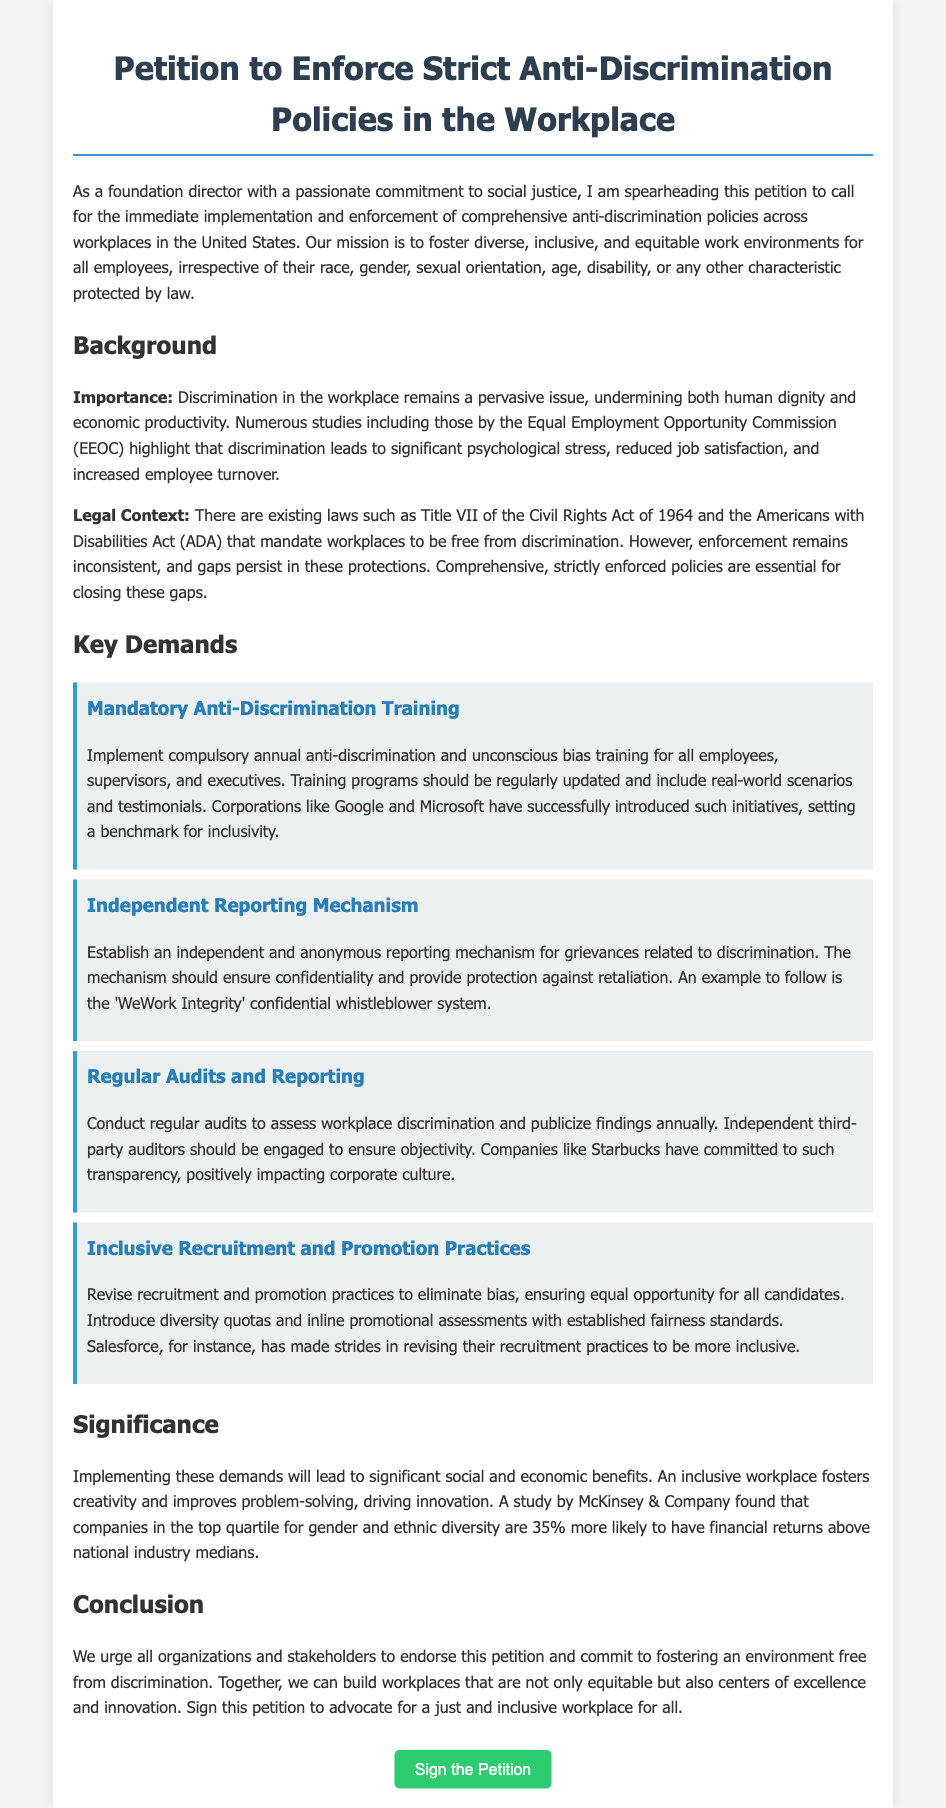what is the title of the petition? The title of the petition is explicitly stated in the document's heading.
Answer: Petition to Enforce Strict Anti-Discrimination Policies in the Workplace who is leading the petition? The introduction section mentions the individual spearheading the petition.
Answer: foundation director what year was the Civil Rights Act enacted? This act is referenced in the legal context of the background section of the document.
Answer: 1964 name one company that introduced inclusive training programs. The demands section includes examples of corporations that have successfully implemented initiatives.
Answer: Google what is one of the key demands of the petition? The section detailing key demands lists several initiatives being called for.
Answer: Mandatory Anti-Discrimination Training how often should anti-discrimination training be conducted? This information is provided in the demands section regarding training frequency.
Answer: annually what is highlighted as a significant benefit of inclusive workplaces? The significance section discusses the advantages of having inclusive work environments.
Answer: financial returns what is the purpose of the independent reporting mechanism? The demands section explains the role of this mechanism in the workplace.
Answer: grievances related to discrimination who conducted a study on the benefits of workplace diversity? The significance section refers to a specific study that highlights diversity benefits.
Answer: McKinsey & Company 